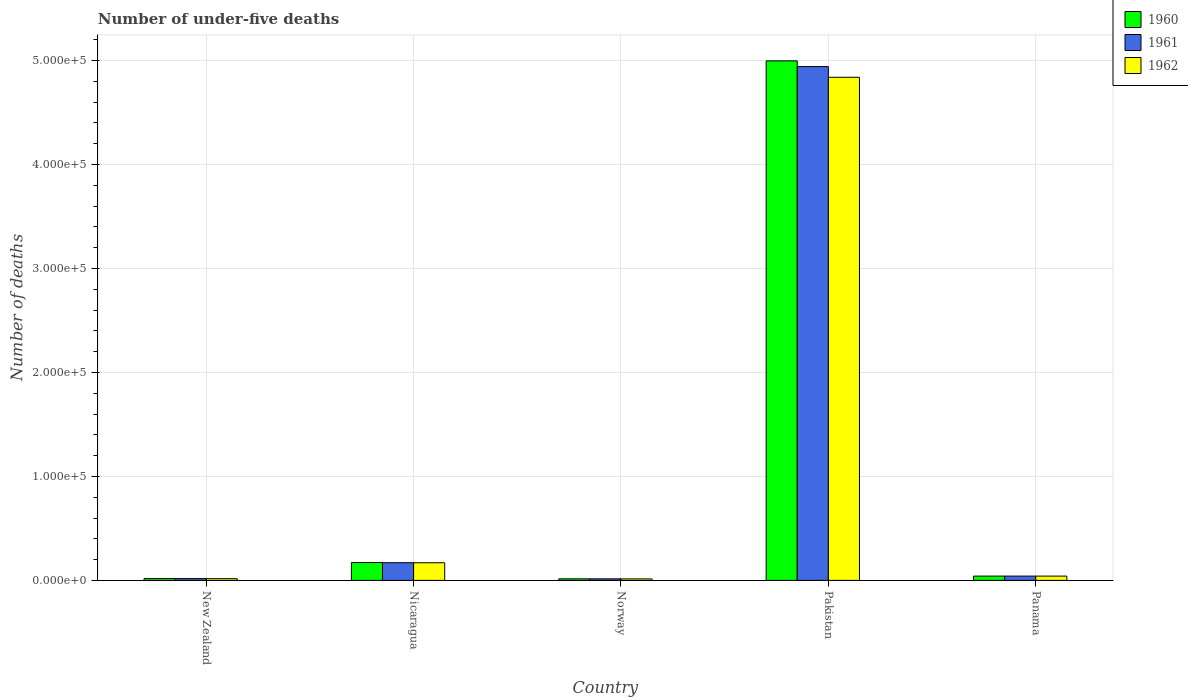Are the number of bars on each tick of the X-axis equal?
Provide a succinct answer. Yes. How many bars are there on the 5th tick from the left?
Offer a very short reply. 3. How many bars are there on the 5th tick from the right?
Offer a terse response. 3. What is the label of the 5th group of bars from the left?
Your answer should be compact. Panama. What is the number of under-five deaths in 1960 in Norway?
Give a very brief answer. 1503. Across all countries, what is the maximum number of under-five deaths in 1961?
Offer a very short reply. 4.94e+05. Across all countries, what is the minimum number of under-five deaths in 1961?
Your response must be concise. 1480. In which country was the number of under-five deaths in 1962 maximum?
Ensure brevity in your answer.  Pakistan. In which country was the number of under-five deaths in 1962 minimum?
Keep it short and to the point. Norway. What is the total number of under-five deaths in 1962 in the graph?
Keep it short and to the point. 5.08e+05. What is the difference between the number of under-five deaths in 1962 in New Zealand and that in Pakistan?
Provide a succinct answer. -4.82e+05. What is the difference between the number of under-five deaths in 1960 in Pakistan and the number of under-five deaths in 1961 in Panama?
Make the answer very short. 4.96e+05. What is the average number of under-five deaths in 1962 per country?
Provide a short and direct response. 1.02e+05. What is the difference between the number of under-five deaths of/in 1961 and number of under-five deaths of/in 1962 in New Zealand?
Offer a terse response. 70. What is the ratio of the number of under-five deaths in 1962 in New Zealand to that in Norway?
Your answer should be very brief. 1.16. Is the difference between the number of under-five deaths in 1961 in Nicaragua and Panama greater than the difference between the number of under-five deaths in 1962 in Nicaragua and Panama?
Give a very brief answer. Yes. What is the difference between the highest and the second highest number of under-five deaths in 1961?
Give a very brief answer. 4.90e+05. What is the difference between the highest and the lowest number of under-five deaths in 1960?
Your answer should be compact. 4.98e+05. In how many countries, is the number of under-five deaths in 1960 greater than the average number of under-five deaths in 1960 taken over all countries?
Ensure brevity in your answer.  1. What does the 1st bar from the right in New Zealand represents?
Keep it short and to the point. 1962. Is it the case that in every country, the sum of the number of under-five deaths in 1961 and number of under-five deaths in 1962 is greater than the number of under-five deaths in 1960?
Your answer should be very brief. Yes. How many bars are there?
Provide a short and direct response. 15. Are all the bars in the graph horizontal?
Ensure brevity in your answer.  No. Does the graph contain any zero values?
Keep it short and to the point. No. How many legend labels are there?
Offer a terse response. 3. How are the legend labels stacked?
Ensure brevity in your answer.  Vertical. What is the title of the graph?
Provide a short and direct response. Number of under-five deaths. Does "2010" appear as one of the legend labels in the graph?
Keep it short and to the point. No. What is the label or title of the X-axis?
Your answer should be very brief. Country. What is the label or title of the Y-axis?
Your answer should be compact. Number of deaths. What is the Number of deaths in 1960 in New Zealand?
Give a very brief answer. 1768. What is the Number of deaths in 1961 in New Zealand?
Ensure brevity in your answer.  1719. What is the Number of deaths in 1962 in New Zealand?
Your answer should be compact. 1649. What is the Number of deaths of 1960 in Nicaragua?
Keep it short and to the point. 1.72e+04. What is the Number of deaths of 1961 in Nicaragua?
Give a very brief answer. 1.70e+04. What is the Number of deaths of 1962 in Nicaragua?
Offer a very short reply. 1.70e+04. What is the Number of deaths of 1960 in Norway?
Provide a succinct answer. 1503. What is the Number of deaths in 1961 in Norway?
Your response must be concise. 1480. What is the Number of deaths in 1962 in Norway?
Make the answer very short. 1422. What is the Number of deaths in 1960 in Pakistan?
Offer a terse response. 5.00e+05. What is the Number of deaths of 1961 in Pakistan?
Ensure brevity in your answer.  4.94e+05. What is the Number of deaths in 1962 in Pakistan?
Offer a terse response. 4.84e+05. What is the Number of deaths of 1960 in Panama?
Provide a short and direct response. 4142. What is the Number of deaths of 1961 in Panama?
Your answer should be very brief. 4139. What is the Number of deaths in 1962 in Panama?
Make the answer very short. 4122. Across all countries, what is the maximum Number of deaths in 1960?
Your answer should be compact. 5.00e+05. Across all countries, what is the maximum Number of deaths of 1961?
Your answer should be very brief. 4.94e+05. Across all countries, what is the maximum Number of deaths in 1962?
Offer a very short reply. 4.84e+05. Across all countries, what is the minimum Number of deaths in 1960?
Keep it short and to the point. 1503. Across all countries, what is the minimum Number of deaths of 1961?
Provide a succinct answer. 1480. Across all countries, what is the minimum Number of deaths of 1962?
Make the answer very short. 1422. What is the total Number of deaths in 1960 in the graph?
Offer a terse response. 5.24e+05. What is the total Number of deaths of 1961 in the graph?
Ensure brevity in your answer.  5.18e+05. What is the total Number of deaths of 1962 in the graph?
Your answer should be very brief. 5.08e+05. What is the difference between the Number of deaths in 1960 in New Zealand and that in Nicaragua?
Provide a short and direct response. -1.54e+04. What is the difference between the Number of deaths of 1961 in New Zealand and that in Nicaragua?
Offer a very short reply. -1.53e+04. What is the difference between the Number of deaths of 1962 in New Zealand and that in Nicaragua?
Keep it short and to the point. -1.53e+04. What is the difference between the Number of deaths of 1960 in New Zealand and that in Norway?
Provide a succinct answer. 265. What is the difference between the Number of deaths of 1961 in New Zealand and that in Norway?
Give a very brief answer. 239. What is the difference between the Number of deaths in 1962 in New Zealand and that in Norway?
Your response must be concise. 227. What is the difference between the Number of deaths in 1960 in New Zealand and that in Pakistan?
Your answer should be compact. -4.98e+05. What is the difference between the Number of deaths in 1961 in New Zealand and that in Pakistan?
Make the answer very short. -4.92e+05. What is the difference between the Number of deaths in 1962 in New Zealand and that in Pakistan?
Provide a succinct answer. -4.82e+05. What is the difference between the Number of deaths of 1960 in New Zealand and that in Panama?
Ensure brevity in your answer.  -2374. What is the difference between the Number of deaths of 1961 in New Zealand and that in Panama?
Provide a short and direct response. -2420. What is the difference between the Number of deaths in 1962 in New Zealand and that in Panama?
Offer a very short reply. -2473. What is the difference between the Number of deaths in 1960 in Nicaragua and that in Norway?
Provide a short and direct response. 1.57e+04. What is the difference between the Number of deaths of 1961 in Nicaragua and that in Norway?
Ensure brevity in your answer.  1.55e+04. What is the difference between the Number of deaths of 1962 in Nicaragua and that in Norway?
Give a very brief answer. 1.55e+04. What is the difference between the Number of deaths in 1960 in Nicaragua and that in Pakistan?
Offer a very short reply. -4.82e+05. What is the difference between the Number of deaths of 1961 in Nicaragua and that in Pakistan?
Your response must be concise. -4.77e+05. What is the difference between the Number of deaths in 1962 in Nicaragua and that in Pakistan?
Ensure brevity in your answer.  -4.67e+05. What is the difference between the Number of deaths of 1960 in Nicaragua and that in Panama?
Your answer should be very brief. 1.30e+04. What is the difference between the Number of deaths in 1961 in Nicaragua and that in Panama?
Your response must be concise. 1.29e+04. What is the difference between the Number of deaths of 1962 in Nicaragua and that in Panama?
Give a very brief answer. 1.28e+04. What is the difference between the Number of deaths of 1960 in Norway and that in Pakistan?
Provide a succinct answer. -4.98e+05. What is the difference between the Number of deaths of 1961 in Norway and that in Pakistan?
Provide a short and direct response. -4.93e+05. What is the difference between the Number of deaths in 1962 in Norway and that in Pakistan?
Provide a short and direct response. -4.82e+05. What is the difference between the Number of deaths in 1960 in Norway and that in Panama?
Provide a succinct answer. -2639. What is the difference between the Number of deaths in 1961 in Norway and that in Panama?
Your response must be concise. -2659. What is the difference between the Number of deaths of 1962 in Norway and that in Panama?
Your answer should be compact. -2700. What is the difference between the Number of deaths in 1960 in Pakistan and that in Panama?
Keep it short and to the point. 4.96e+05. What is the difference between the Number of deaths in 1961 in Pakistan and that in Panama?
Your answer should be very brief. 4.90e+05. What is the difference between the Number of deaths in 1962 in Pakistan and that in Panama?
Make the answer very short. 4.80e+05. What is the difference between the Number of deaths in 1960 in New Zealand and the Number of deaths in 1961 in Nicaragua?
Your response must be concise. -1.52e+04. What is the difference between the Number of deaths of 1960 in New Zealand and the Number of deaths of 1962 in Nicaragua?
Make the answer very short. -1.52e+04. What is the difference between the Number of deaths in 1961 in New Zealand and the Number of deaths in 1962 in Nicaragua?
Give a very brief answer. -1.52e+04. What is the difference between the Number of deaths in 1960 in New Zealand and the Number of deaths in 1961 in Norway?
Make the answer very short. 288. What is the difference between the Number of deaths in 1960 in New Zealand and the Number of deaths in 1962 in Norway?
Your response must be concise. 346. What is the difference between the Number of deaths in 1961 in New Zealand and the Number of deaths in 1962 in Norway?
Your answer should be very brief. 297. What is the difference between the Number of deaths in 1960 in New Zealand and the Number of deaths in 1961 in Pakistan?
Give a very brief answer. -4.92e+05. What is the difference between the Number of deaths in 1960 in New Zealand and the Number of deaths in 1962 in Pakistan?
Ensure brevity in your answer.  -4.82e+05. What is the difference between the Number of deaths of 1961 in New Zealand and the Number of deaths of 1962 in Pakistan?
Keep it short and to the point. -4.82e+05. What is the difference between the Number of deaths of 1960 in New Zealand and the Number of deaths of 1961 in Panama?
Provide a succinct answer. -2371. What is the difference between the Number of deaths of 1960 in New Zealand and the Number of deaths of 1962 in Panama?
Your answer should be very brief. -2354. What is the difference between the Number of deaths in 1961 in New Zealand and the Number of deaths in 1962 in Panama?
Ensure brevity in your answer.  -2403. What is the difference between the Number of deaths of 1960 in Nicaragua and the Number of deaths of 1961 in Norway?
Give a very brief answer. 1.57e+04. What is the difference between the Number of deaths of 1960 in Nicaragua and the Number of deaths of 1962 in Norway?
Ensure brevity in your answer.  1.57e+04. What is the difference between the Number of deaths in 1961 in Nicaragua and the Number of deaths in 1962 in Norway?
Your response must be concise. 1.56e+04. What is the difference between the Number of deaths in 1960 in Nicaragua and the Number of deaths in 1961 in Pakistan?
Provide a short and direct response. -4.77e+05. What is the difference between the Number of deaths of 1960 in Nicaragua and the Number of deaths of 1962 in Pakistan?
Give a very brief answer. -4.67e+05. What is the difference between the Number of deaths in 1961 in Nicaragua and the Number of deaths in 1962 in Pakistan?
Your response must be concise. -4.67e+05. What is the difference between the Number of deaths of 1960 in Nicaragua and the Number of deaths of 1961 in Panama?
Your response must be concise. 1.30e+04. What is the difference between the Number of deaths in 1960 in Nicaragua and the Number of deaths in 1962 in Panama?
Offer a very short reply. 1.30e+04. What is the difference between the Number of deaths in 1961 in Nicaragua and the Number of deaths in 1962 in Panama?
Your answer should be very brief. 1.29e+04. What is the difference between the Number of deaths in 1960 in Norway and the Number of deaths in 1961 in Pakistan?
Your answer should be compact. -4.93e+05. What is the difference between the Number of deaths of 1960 in Norway and the Number of deaths of 1962 in Pakistan?
Ensure brevity in your answer.  -4.82e+05. What is the difference between the Number of deaths of 1961 in Norway and the Number of deaths of 1962 in Pakistan?
Keep it short and to the point. -4.82e+05. What is the difference between the Number of deaths of 1960 in Norway and the Number of deaths of 1961 in Panama?
Keep it short and to the point. -2636. What is the difference between the Number of deaths in 1960 in Norway and the Number of deaths in 1962 in Panama?
Ensure brevity in your answer.  -2619. What is the difference between the Number of deaths of 1961 in Norway and the Number of deaths of 1962 in Panama?
Provide a short and direct response. -2642. What is the difference between the Number of deaths in 1960 in Pakistan and the Number of deaths in 1961 in Panama?
Your response must be concise. 4.96e+05. What is the difference between the Number of deaths in 1960 in Pakistan and the Number of deaths in 1962 in Panama?
Give a very brief answer. 4.96e+05. What is the difference between the Number of deaths in 1961 in Pakistan and the Number of deaths in 1962 in Panama?
Make the answer very short. 4.90e+05. What is the average Number of deaths of 1960 per country?
Your response must be concise. 1.05e+05. What is the average Number of deaths of 1961 per country?
Give a very brief answer. 1.04e+05. What is the average Number of deaths in 1962 per country?
Ensure brevity in your answer.  1.02e+05. What is the difference between the Number of deaths in 1960 and Number of deaths in 1961 in New Zealand?
Your answer should be very brief. 49. What is the difference between the Number of deaths of 1960 and Number of deaths of 1962 in New Zealand?
Your response must be concise. 119. What is the difference between the Number of deaths of 1961 and Number of deaths of 1962 in New Zealand?
Keep it short and to the point. 70. What is the difference between the Number of deaths of 1960 and Number of deaths of 1961 in Nicaragua?
Your answer should be very brief. 167. What is the difference between the Number of deaths in 1960 and Number of deaths in 1962 in Nicaragua?
Provide a short and direct response. 207. What is the difference between the Number of deaths of 1961 and Number of deaths of 1962 in Nicaragua?
Your response must be concise. 40. What is the difference between the Number of deaths in 1960 and Number of deaths in 1962 in Norway?
Provide a succinct answer. 81. What is the difference between the Number of deaths of 1960 and Number of deaths of 1961 in Pakistan?
Your answer should be compact. 5515. What is the difference between the Number of deaths of 1960 and Number of deaths of 1962 in Pakistan?
Ensure brevity in your answer.  1.58e+04. What is the difference between the Number of deaths in 1961 and Number of deaths in 1962 in Pakistan?
Your answer should be very brief. 1.03e+04. What is the ratio of the Number of deaths of 1960 in New Zealand to that in Nicaragua?
Offer a terse response. 0.1. What is the ratio of the Number of deaths in 1961 in New Zealand to that in Nicaragua?
Offer a terse response. 0.1. What is the ratio of the Number of deaths in 1962 in New Zealand to that in Nicaragua?
Make the answer very short. 0.1. What is the ratio of the Number of deaths of 1960 in New Zealand to that in Norway?
Your response must be concise. 1.18. What is the ratio of the Number of deaths in 1961 in New Zealand to that in Norway?
Your response must be concise. 1.16. What is the ratio of the Number of deaths in 1962 in New Zealand to that in Norway?
Your response must be concise. 1.16. What is the ratio of the Number of deaths of 1960 in New Zealand to that in Pakistan?
Offer a terse response. 0. What is the ratio of the Number of deaths in 1961 in New Zealand to that in Pakistan?
Ensure brevity in your answer.  0. What is the ratio of the Number of deaths in 1962 in New Zealand to that in Pakistan?
Your answer should be compact. 0. What is the ratio of the Number of deaths in 1960 in New Zealand to that in Panama?
Your answer should be compact. 0.43. What is the ratio of the Number of deaths in 1961 in New Zealand to that in Panama?
Offer a very short reply. 0.42. What is the ratio of the Number of deaths of 1962 in New Zealand to that in Panama?
Keep it short and to the point. 0.4. What is the ratio of the Number of deaths in 1960 in Nicaragua to that in Norway?
Provide a succinct answer. 11.42. What is the ratio of the Number of deaths in 1961 in Nicaragua to that in Norway?
Your answer should be very brief. 11.49. What is the ratio of the Number of deaths of 1962 in Nicaragua to that in Norway?
Offer a very short reply. 11.93. What is the ratio of the Number of deaths of 1960 in Nicaragua to that in Pakistan?
Your response must be concise. 0.03. What is the ratio of the Number of deaths in 1961 in Nicaragua to that in Pakistan?
Provide a succinct answer. 0.03. What is the ratio of the Number of deaths of 1962 in Nicaragua to that in Pakistan?
Your response must be concise. 0.04. What is the ratio of the Number of deaths of 1960 in Nicaragua to that in Panama?
Give a very brief answer. 4.15. What is the ratio of the Number of deaths in 1961 in Nicaragua to that in Panama?
Offer a very short reply. 4.11. What is the ratio of the Number of deaths of 1962 in Nicaragua to that in Panama?
Provide a succinct answer. 4.12. What is the ratio of the Number of deaths in 1960 in Norway to that in Pakistan?
Your answer should be very brief. 0. What is the ratio of the Number of deaths in 1961 in Norway to that in Pakistan?
Your answer should be very brief. 0. What is the ratio of the Number of deaths of 1962 in Norway to that in Pakistan?
Your answer should be compact. 0. What is the ratio of the Number of deaths of 1960 in Norway to that in Panama?
Your response must be concise. 0.36. What is the ratio of the Number of deaths of 1961 in Norway to that in Panama?
Your answer should be very brief. 0.36. What is the ratio of the Number of deaths in 1962 in Norway to that in Panama?
Make the answer very short. 0.34. What is the ratio of the Number of deaths in 1960 in Pakistan to that in Panama?
Your answer should be compact. 120.63. What is the ratio of the Number of deaths in 1961 in Pakistan to that in Panama?
Provide a succinct answer. 119.38. What is the ratio of the Number of deaths in 1962 in Pakistan to that in Panama?
Provide a succinct answer. 117.38. What is the difference between the highest and the second highest Number of deaths in 1960?
Offer a terse response. 4.82e+05. What is the difference between the highest and the second highest Number of deaths in 1961?
Give a very brief answer. 4.77e+05. What is the difference between the highest and the second highest Number of deaths in 1962?
Keep it short and to the point. 4.67e+05. What is the difference between the highest and the lowest Number of deaths in 1960?
Keep it short and to the point. 4.98e+05. What is the difference between the highest and the lowest Number of deaths of 1961?
Your response must be concise. 4.93e+05. What is the difference between the highest and the lowest Number of deaths of 1962?
Offer a very short reply. 4.82e+05. 